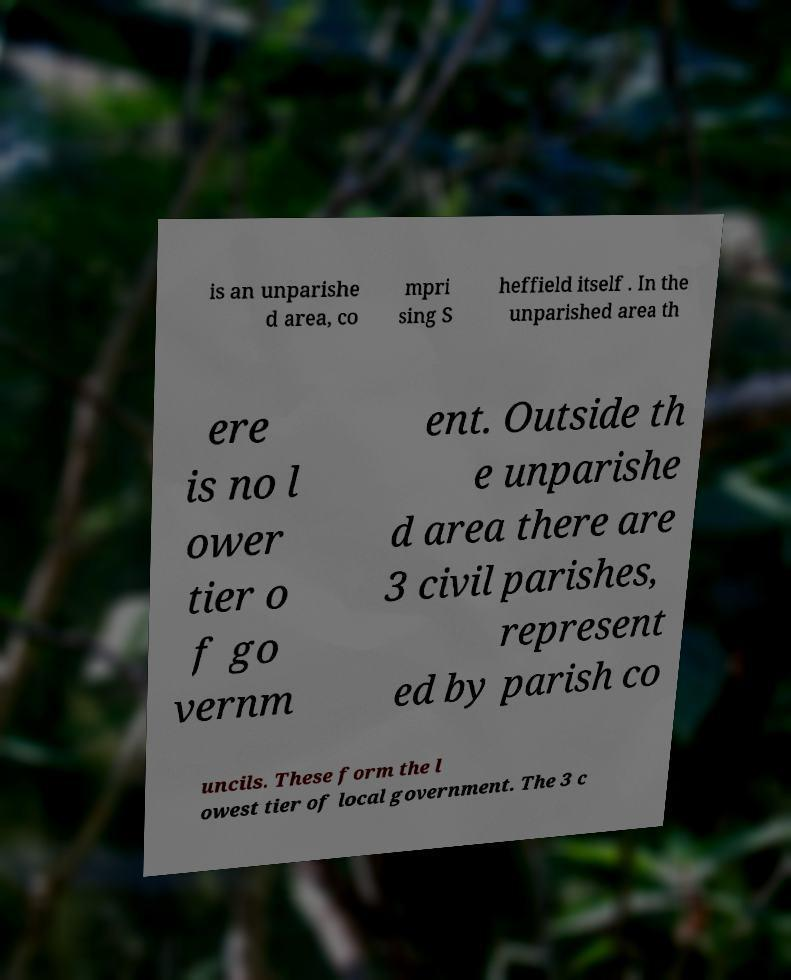Please read and relay the text visible in this image. What does it say? is an unparishe d area, co mpri sing S heffield itself . In the unparished area th ere is no l ower tier o f go vernm ent. Outside th e unparishe d area there are 3 civil parishes, represent ed by parish co uncils. These form the l owest tier of local government. The 3 c 